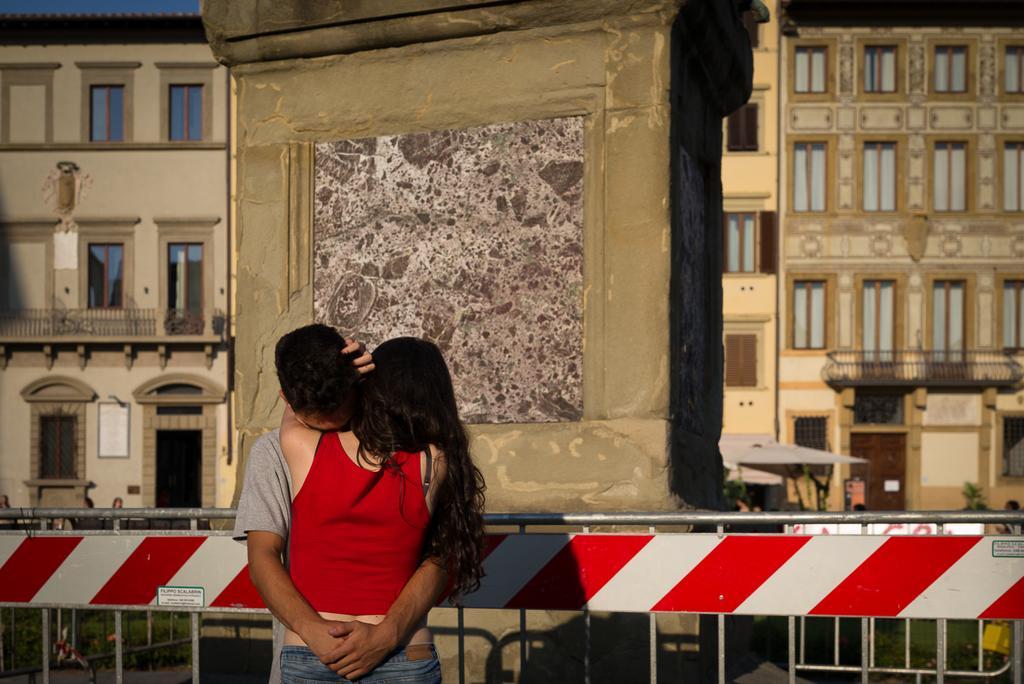In one or two sentences, can you explain what this image depicts? In this image I can see two people with ash, red and blue color dresses. In the background I can see the railing, building with windows and railing and the sky. 